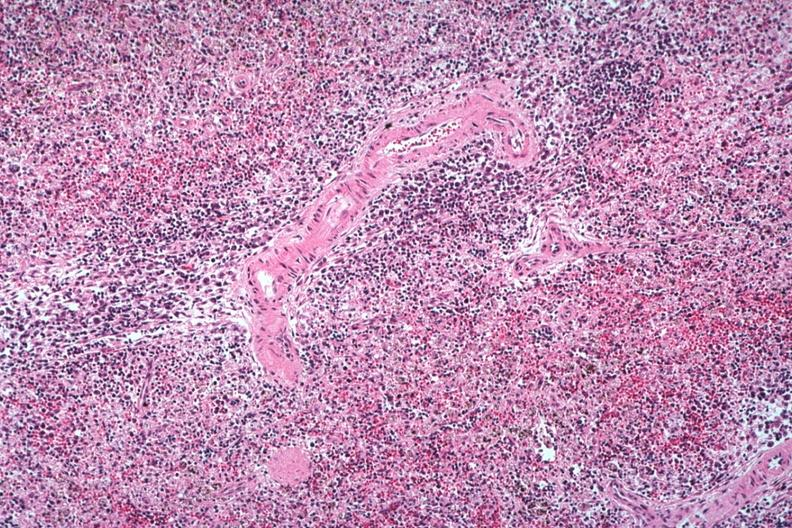what is present?
Answer the question using a single word or phrase. Immunoblastic reaction characteristic of viral infection 